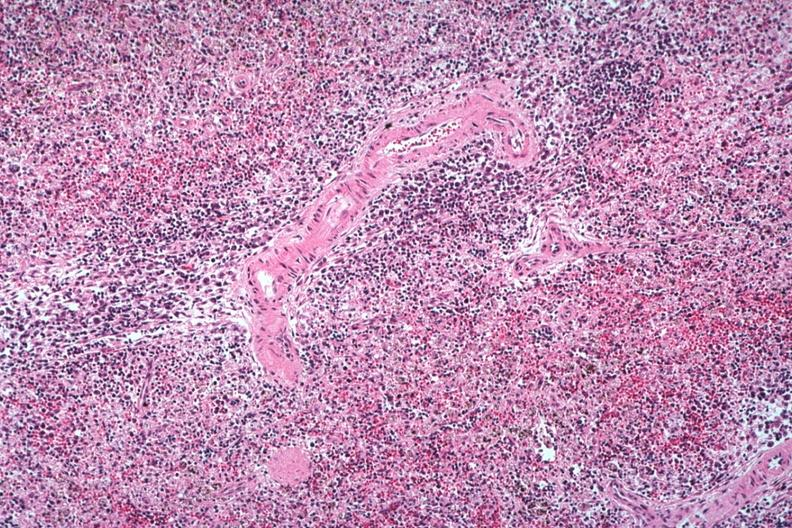what is present?
Answer the question using a single word or phrase. Immunoblastic reaction characteristic of viral infection 